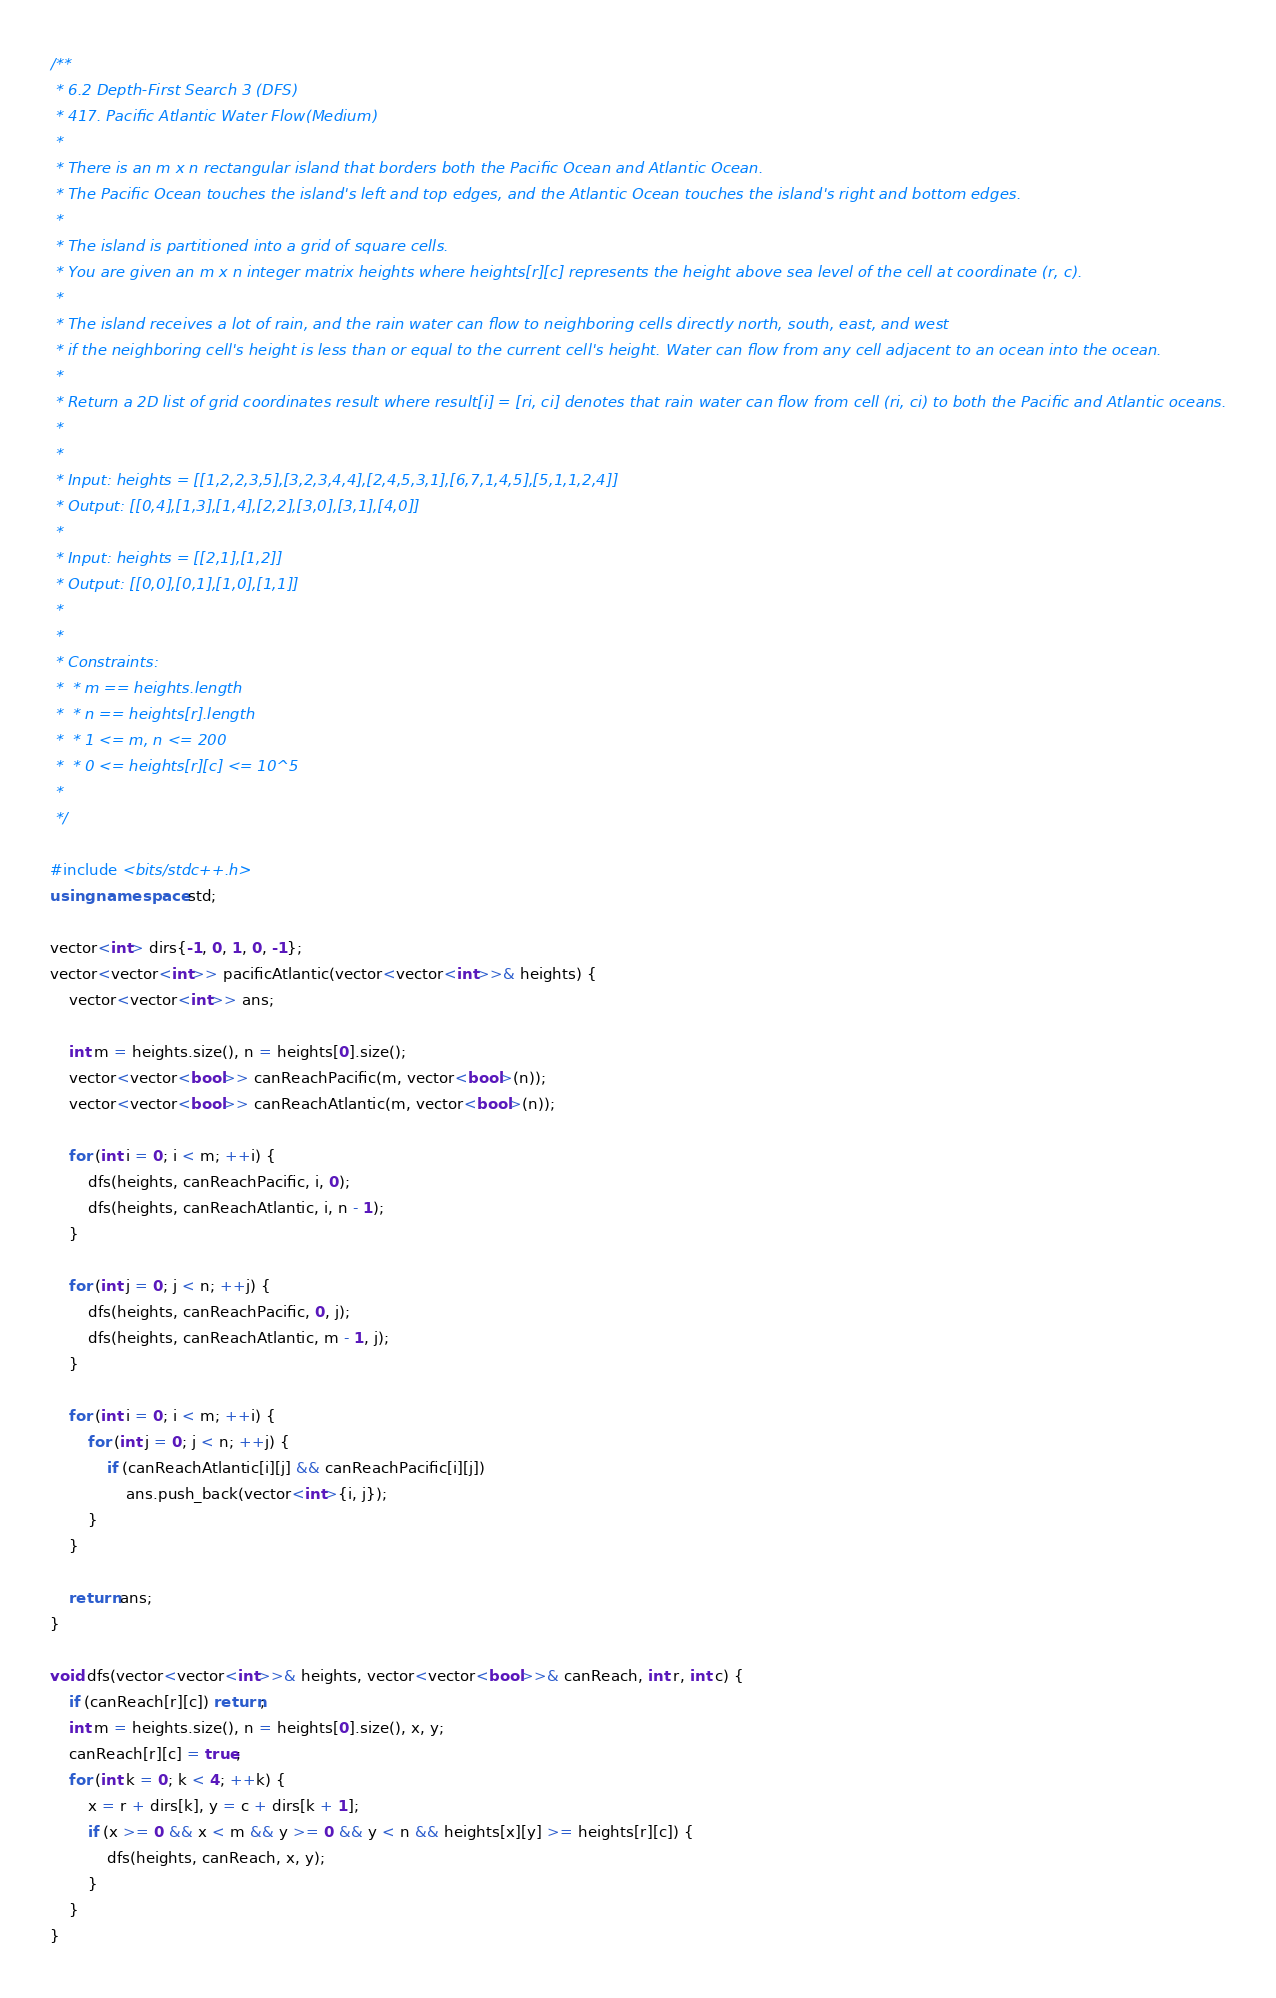<code> <loc_0><loc_0><loc_500><loc_500><_C++_>/**
 * 6.2 Depth-First Search 3 (DFS)
 * 417. Pacific Atlantic Water Flow(Medium)
 * 
 * There is an m x n rectangular island that borders both the Pacific Ocean and Atlantic Ocean. 
 * The Pacific Ocean touches the island's left and top edges, and the Atlantic Ocean touches the island's right and bottom edges.
 * 
 * The island is partitioned into a grid of square cells. 
 * You are given an m x n integer matrix heights where heights[r][c] represents the height above sea level of the cell at coordinate (r, c).
 * 
 * The island receives a lot of rain, and the rain water can flow to neighboring cells directly north, south, east, and west 
 * if the neighboring cell's height is less than or equal to the current cell's height. Water can flow from any cell adjacent to an ocean into the ocean.
 * 
 * Return a 2D list of grid coordinates result where result[i] = [ri, ci] denotes that rain water can flow from cell (ri, ci) to both the Pacific and Atlantic oceans.
 * 
 * 
 * Input: heights = [[1,2,2,3,5],[3,2,3,4,4],[2,4,5,3,1],[6,7,1,4,5],[5,1,1,2,4]]
 * Output: [[0,4],[1,3],[1,4],[2,2],[3,0],[3,1],[4,0]]
 * 
 * Input: heights = [[2,1],[1,2]]
 * Output: [[0,0],[0,1],[1,0],[1,1]]
 * 
 * 
 * Constraints:
 *  * m == heights.length
 *  * n == heights[r].length
 *  * 1 <= m, n <= 200
 *  * 0 <= heights[r][c] <= 10^5
 * 
 */

#include <bits/stdc++.h>
using namespace std;

vector<int> dirs{-1, 0, 1, 0, -1};
vector<vector<int>> pacificAtlantic(vector<vector<int>>& heights) {
    vector<vector<int>> ans;

    int m = heights.size(), n = heights[0].size();
    vector<vector<bool>> canReachPacific(m, vector<bool>(n));
    vector<vector<bool>> canReachAtlantic(m, vector<bool>(n));

    for (int i = 0; i < m; ++i) { 
        dfs(heights, canReachPacific, i, 0); 
        dfs(heights, canReachAtlantic, i, n - 1);
    }

    for (int j = 0; j < n; ++j) {
        dfs(heights, canReachPacific, 0, j); 
        dfs(heights, canReachAtlantic, m - 1, j);
    }

    for (int i = 0; i < m; ++i) {
        for (int j = 0; j < n; ++j) {
            if (canReachAtlantic[i][j] && canReachPacific[i][j]) 
                ans.push_back(vector<int>{i, j});
        }
    }

    return ans;
}

void dfs(vector<vector<int>>& heights, vector<vector<bool>>& canReach, int r, int c) {
    if (canReach[r][c]) return;
    int m = heights.size(), n = heights[0].size(), x, y;
    canReach[r][c] = true;
    for (int k = 0; k < 4; ++k) {
        x = r + dirs[k], y = c + dirs[k + 1];
        if (x >= 0 && x < m && y >= 0 && y < n && heights[x][y] >= heights[r][c]) {
            dfs(heights, canReach, x, y);
        }
    }
}</code> 